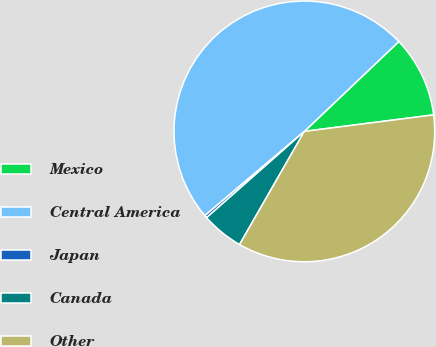Convert chart to OTSL. <chart><loc_0><loc_0><loc_500><loc_500><pie_chart><fcel>Mexico<fcel>Central America<fcel>Japan<fcel>Canada<fcel>Other<nl><fcel>10.08%<fcel>49.08%<fcel>0.33%<fcel>5.21%<fcel>35.3%<nl></chart> 